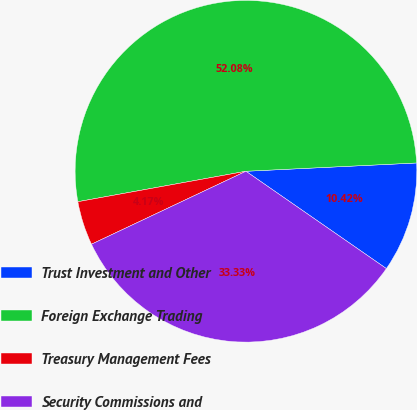Convert chart. <chart><loc_0><loc_0><loc_500><loc_500><pie_chart><fcel>Trust Investment and Other<fcel>Foreign Exchange Trading<fcel>Treasury Management Fees<fcel>Security Commissions and<nl><fcel>10.42%<fcel>52.08%<fcel>4.17%<fcel>33.33%<nl></chart> 